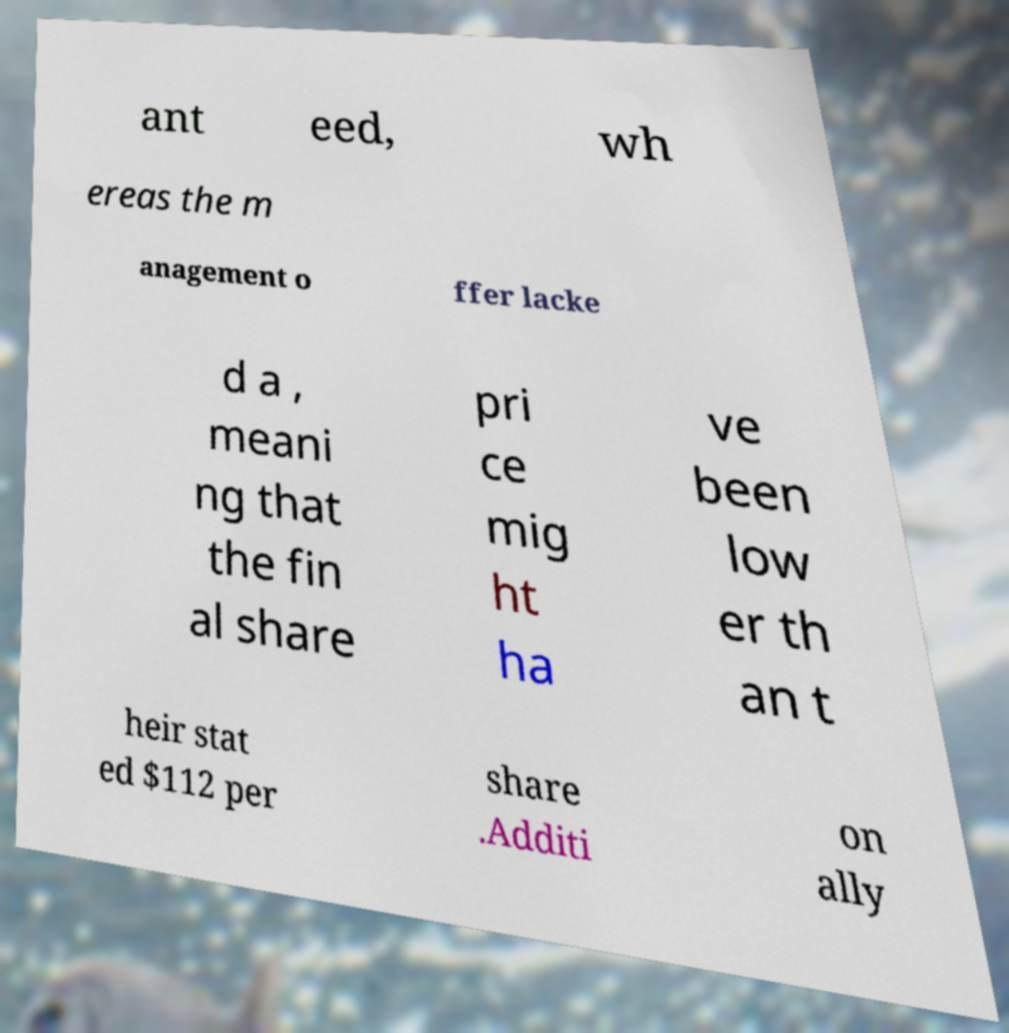What messages or text are displayed in this image? I need them in a readable, typed format. ant eed, wh ereas the m anagement o ffer lacke d a , meani ng that the fin al share pri ce mig ht ha ve been low er th an t heir stat ed $112 per share .Additi on ally 